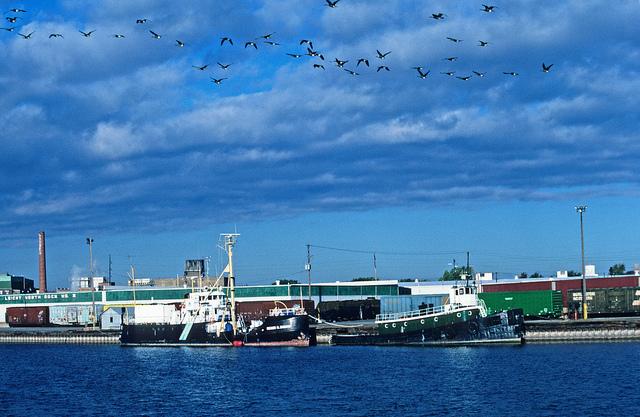What is on the left side of photo?
Concise answer only. Boat. How many birds are in the sky?
Give a very brief answer. 37. What is in the water?
Keep it brief. Boats. What kind of area is this?
Quick response, please. Harbor. 